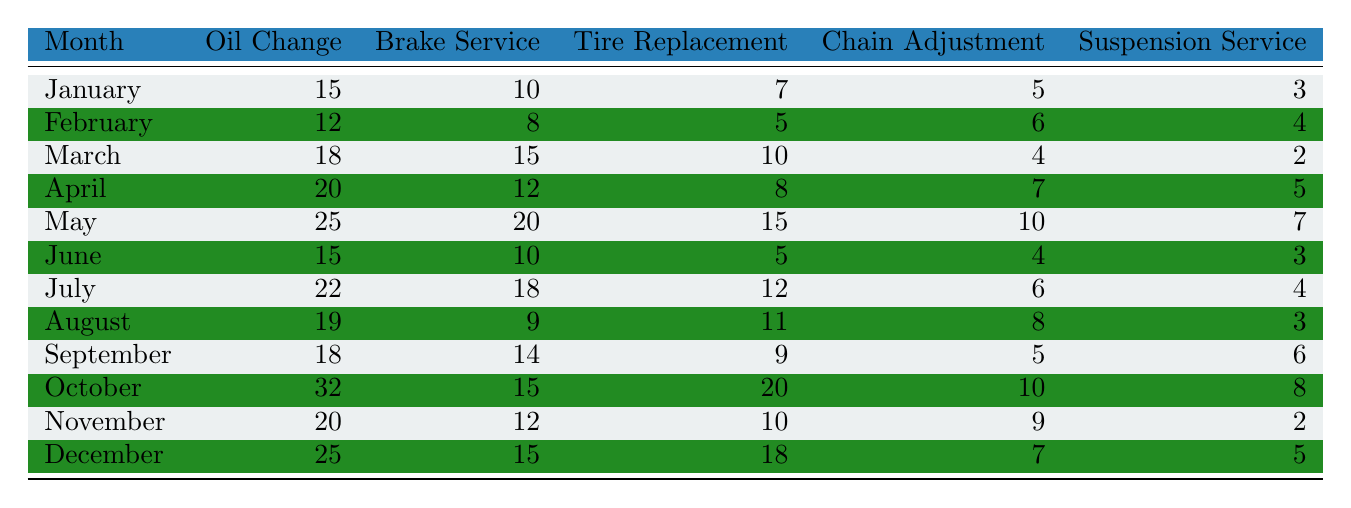What is the total number of oil changes performed in April? Referring to the table, in April, the number of oil changes is listed as 20. Thus, the total for that month is 20.
Answer: 20 In which month were the most tire replacements done? By scanning the table, October has the highest number of tire replacements at 20. Therefore, October is the month with the most tire replacements.
Answer: October What is the average number of brake services performed in the first quarter (January to March)? To find the average, add the number of brake services for January (10), February (8), and March (15): 10 + 8 + 15 = 33. There are 3 months, so divide 33 by 3: 33 / 3 = 11.
Answer: 11 Was there more chain adjustment work done in June compared to August? In June, there were 4 chain adjustments, while in August there were 8. Since 4 is less than 8, we conclude that there was less chain adjustment work done in June.
Answer: No How many total maintenance services were performed in May compared to November? For May, sum up all the maintenance services: 25 (oil change) + 20 (brake service) + 15 (tire replacement) + 10 (chain adjustment) + 7 (suspension service) = 77. For November, the total is: 20 + 12 + 10 + 9 + 2 = 63. Since 77 is greater than 63, May had more services.
Answer: May What percentage of the total services in December were tire replacements? In December, the total services are 25 (oil change) + 15 (brake service) + 18 (tire replacement) + 7 (chain adjustment) + 5 (suspension service) = 70. Tire replacements were 18. The percentage is (18 / 70) * 100, which is approximately 25.71%.
Answer: Approximately 25.71% How does the total number of suspension services in the year compare between the first half and the second half? First, sum suspension services from January to June: 3 + 4 + 2 + 5 + 7 + 3 = 24. Then sum from July to December: 4 + 3 + 6 + 8 + 2 + 5 = 28. Since 24 is less than 28, the second half had more suspension services.
Answer: Yes Which type of maintenance had the least occurrences overall in January? In January, the least occurring type of maintenance is the suspension service, which was performed 3 times compared to the other categories.
Answer: Suspension Service 